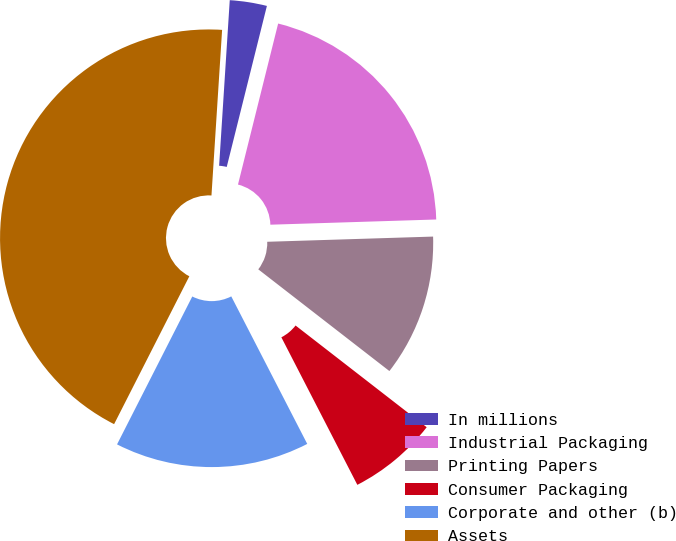<chart> <loc_0><loc_0><loc_500><loc_500><pie_chart><fcel>In millions<fcel>Industrial Packaging<fcel>Printing Papers<fcel>Consumer Packaging<fcel>Corporate and other (b)<fcel>Assets<nl><fcel>2.87%<fcel>20.61%<fcel>11.0%<fcel>6.93%<fcel>15.06%<fcel>43.53%<nl></chart> 